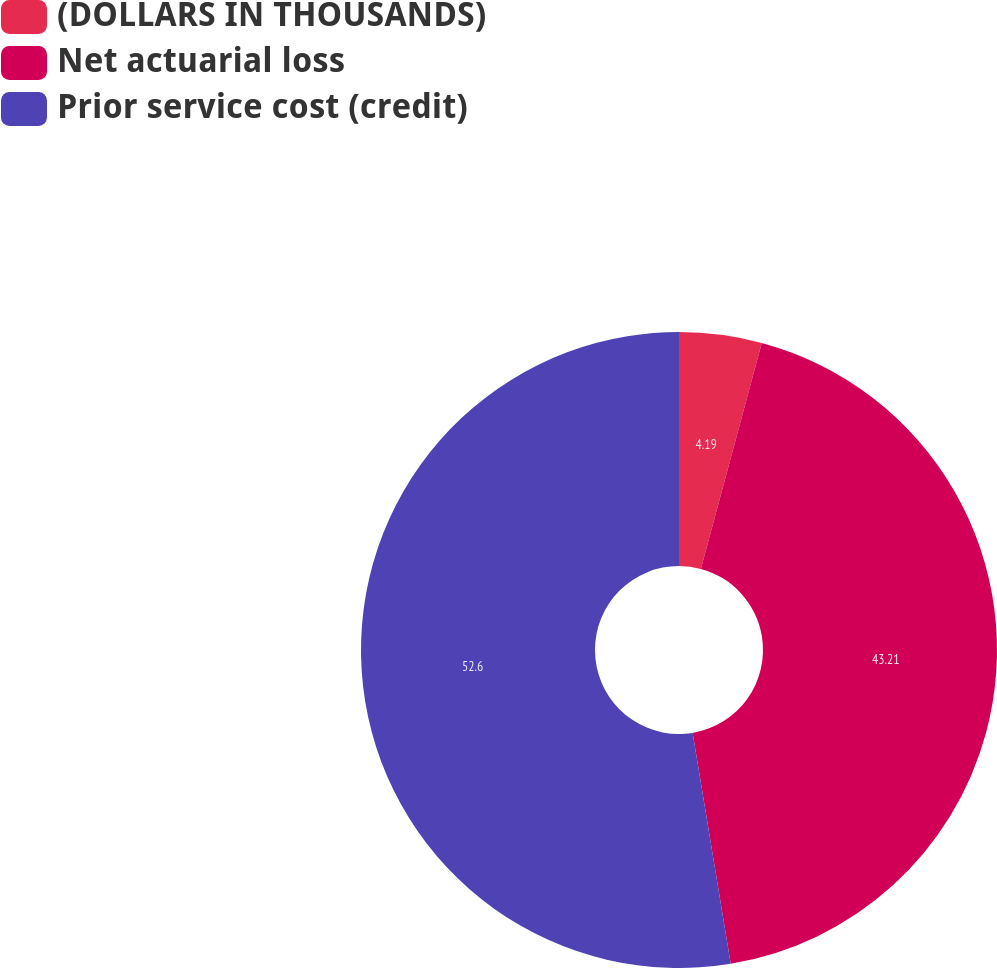Convert chart to OTSL. <chart><loc_0><loc_0><loc_500><loc_500><pie_chart><fcel>(DOLLARS IN THOUSANDS)<fcel>Net actuarial loss<fcel>Prior service cost (credit)<nl><fcel>4.19%<fcel>43.21%<fcel>52.6%<nl></chart> 